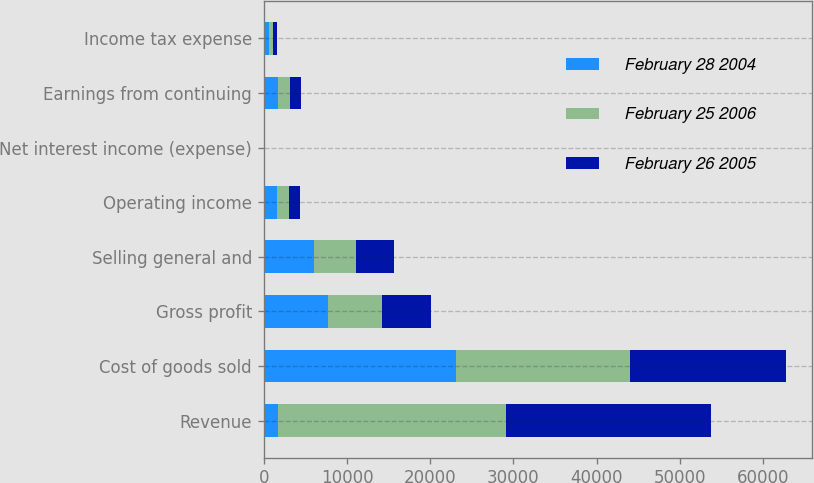<chart> <loc_0><loc_0><loc_500><loc_500><stacked_bar_chart><ecel><fcel>Revenue<fcel>Cost of goods sold<fcel>Gross profit<fcel>Selling general and<fcel>Operating income<fcel>Net interest income (expense)<fcel>Earnings from continuing<fcel>Income tax expense<nl><fcel>February 28 2004<fcel>1721<fcel>23122<fcel>7726<fcel>6082<fcel>1644<fcel>77<fcel>1721<fcel>581<nl><fcel>February 25 2006<fcel>27433<fcel>20938<fcel>6495<fcel>5053<fcel>1442<fcel>1<fcel>1443<fcel>509<nl><fcel>February 26 2005<fcel>24548<fcel>18677<fcel>5871<fcel>4567<fcel>1304<fcel>8<fcel>1296<fcel>496<nl></chart> 